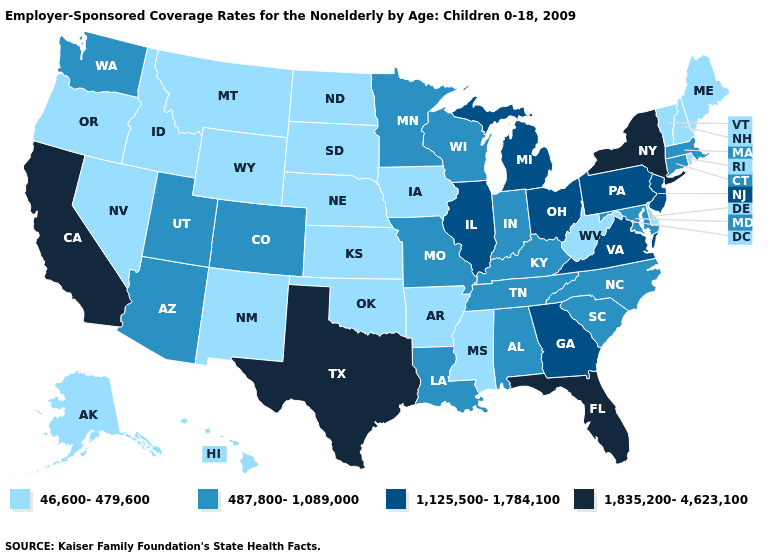What is the highest value in the South ?
Keep it brief. 1,835,200-4,623,100. Name the states that have a value in the range 1,835,200-4,623,100?
Write a very short answer. California, Florida, New York, Texas. Does the first symbol in the legend represent the smallest category?
Answer briefly. Yes. Is the legend a continuous bar?
Keep it brief. No. What is the value of Tennessee?
Short answer required. 487,800-1,089,000. Does Nebraska have the same value as Utah?
Concise answer only. No. What is the value of Alabama?
Be succinct. 487,800-1,089,000. Which states have the lowest value in the South?
Keep it brief. Arkansas, Delaware, Mississippi, Oklahoma, West Virginia. Among the states that border Michigan , which have the lowest value?
Quick response, please. Indiana, Wisconsin. Does Connecticut have the highest value in the USA?
Keep it brief. No. Does Nebraska have a higher value than Iowa?
Write a very short answer. No. What is the highest value in the South ?
Give a very brief answer. 1,835,200-4,623,100. Does Nebraska have the same value as Mississippi?
Write a very short answer. Yes. Which states have the highest value in the USA?
Keep it brief. California, Florida, New York, Texas. What is the value of Indiana?
Be succinct. 487,800-1,089,000. 